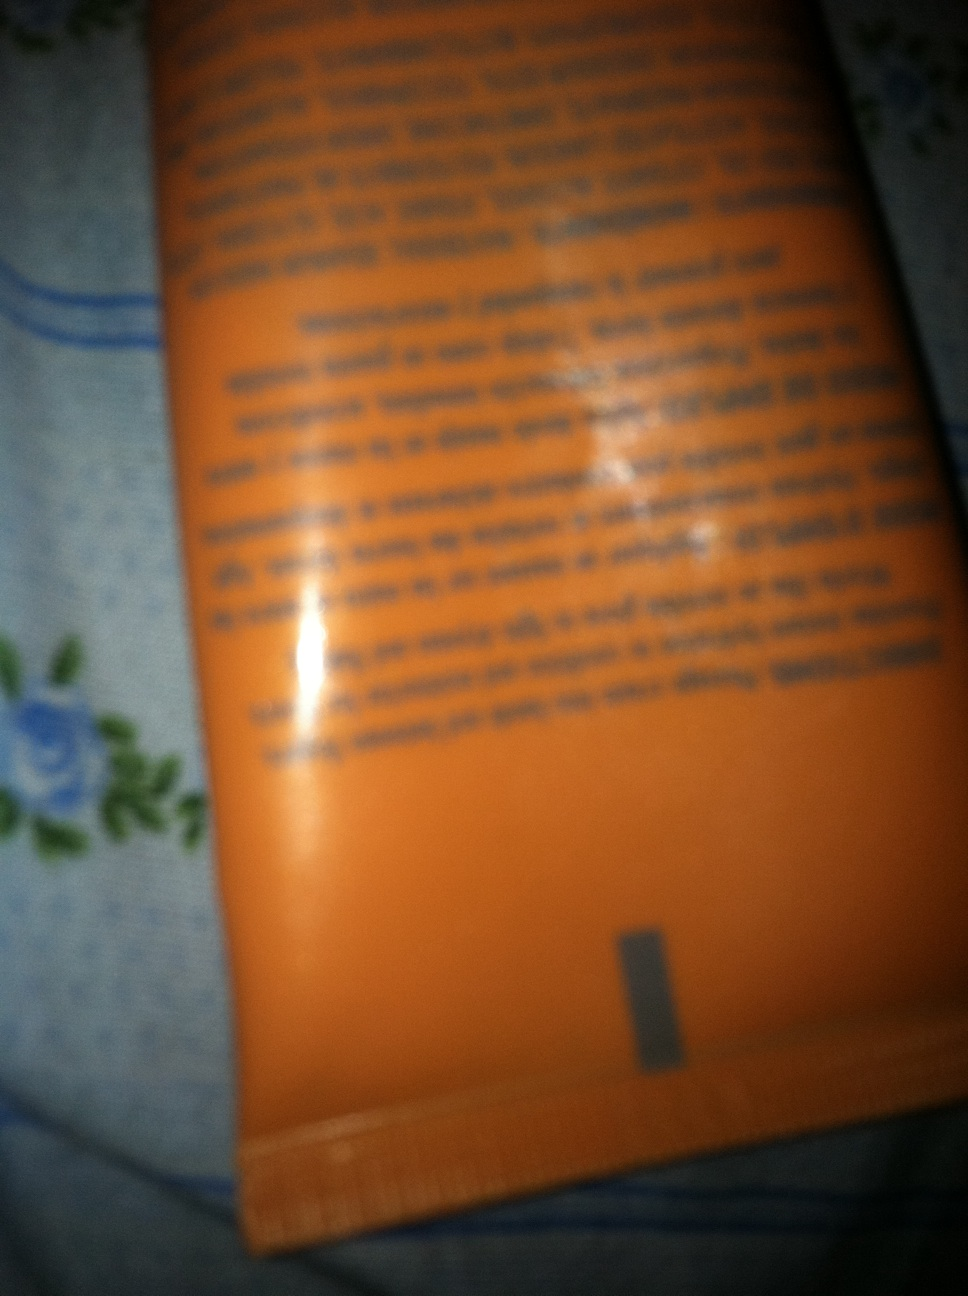Can you please tell me what is in this tube, I think it's hand cream but I'm not sure thank you. Although the image is blurry and the text is difficult to read, from what is visible, it seems to be some type of cosmetic product. If you suspect it's hand cream, that could be possible given the tube packaging commonly used for such products. Always check the label clearly when possible or test a small amount to confirm. 